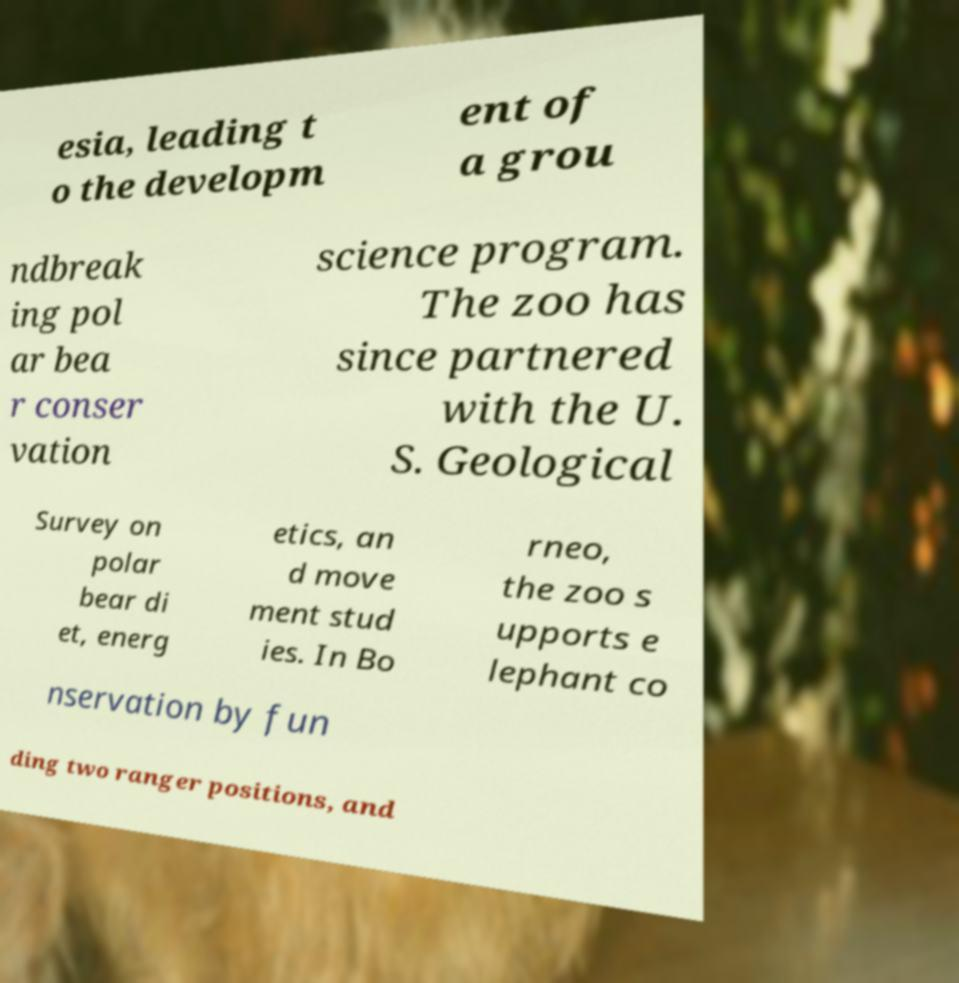Please identify and transcribe the text found in this image. esia, leading t o the developm ent of a grou ndbreak ing pol ar bea r conser vation science program. The zoo has since partnered with the U. S. Geological Survey on polar bear di et, energ etics, an d move ment stud ies. In Bo rneo, the zoo s upports e lephant co nservation by fun ding two ranger positions, and 